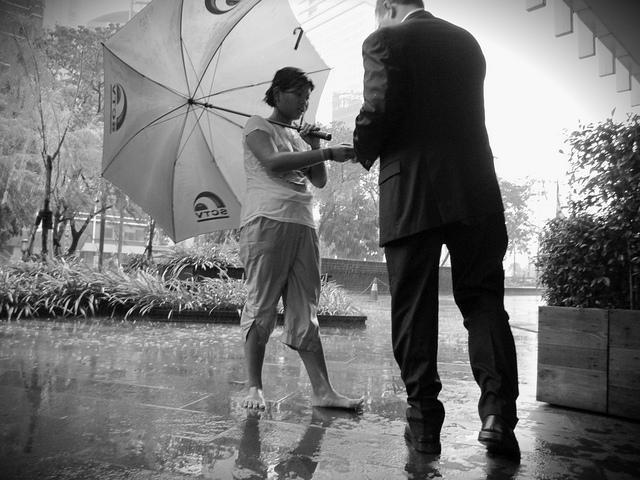What is she giving the man?
From the following set of four choices, select the accurate answer to respond to the question.
Options: Water, drugs, change, food. Change. 